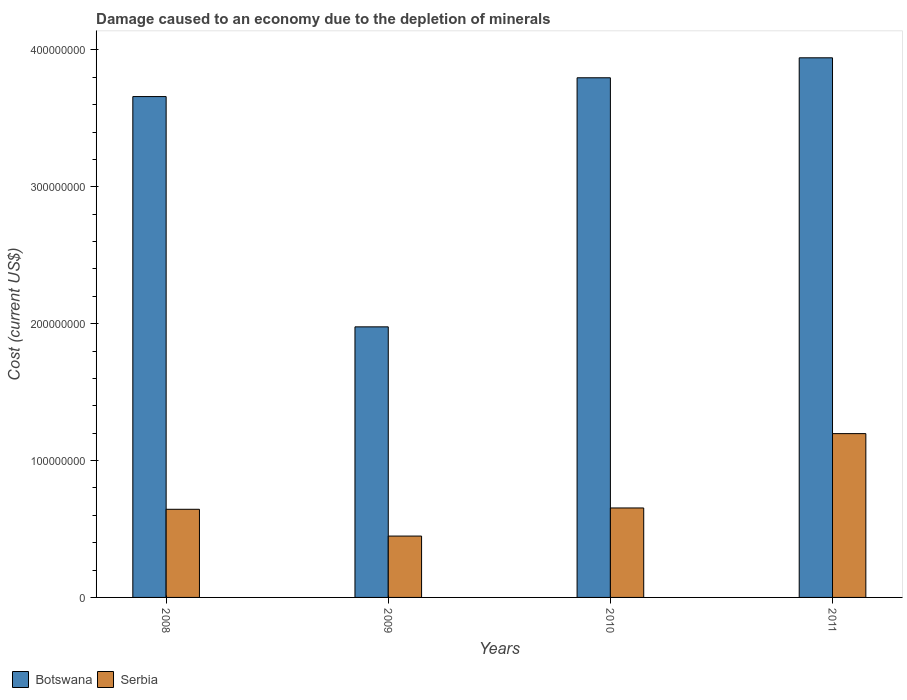How many different coloured bars are there?
Your answer should be compact. 2. How many groups of bars are there?
Offer a very short reply. 4. Are the number of bars per tick equal to the number of legend labels?
Your answer should be very brief. Yes. Are the number of bars on each tick of the X-axis equal?
Make the answer very short. Yes. How many bars are there on the 1st tick from the right?
Give a very brief answer. 2. What is the label of the 2nd group of bars from the left?
Make the answer very short. 2009. What is the cost of damage caused due to the depletion of minerals in Serbia in 2011?
Offer a very short reply. 1.20e+08. Across all years, what is the maximum cost of damage caused due to the depletion of minerals in Serbia?
Offer a very short reply. 1.20e+08. Across all years, what is the minimum cost of damage caused due to the depletion of minerals in Botswana?
Provide a short and direct response. 1.98e+08. What is the total cost of damage caused due to the depletion of minerals in Botswana in the graph?
Ensure brevity in your answer.  1.34e+09. What is the difference between the cost of damage caused due to the depletion of minerals in Botswana in 2008 and that in 2010?
Provide a short and direct response. -1.37e+07. What is the difference between the cost of damage caused due to the depletion of minerals in Botswana in 2011 and the cost of damage caused due to the depletion of minerals in Serbia in 2010?
Make the answer very short. 3.29e+08. What is the average cost of damage caused due to the depletion of minerals in Botswana per year?
Ensure brevity in your answer.  3.34e+08. In the year 2010, what is the difference between the cost of damage caused due to the depletion of minerals in Serbia and cost of damage caused due to the depletion of minerals in Botswana?
Your response must be concise. -3.14e+08. What is the ratio of the cost of damage caused due to the depletion of minerals in Serbia in 2009 to that in 2010?
Your answer should be very brief. 0.69. Is the cost of damage caused due to the depletion of minerals in Serbia in 2009 less than that in 2010?
Offer a very short reply. Yes. Is the difference between the cost of damage caused due to the depletion of minerals in Serbia in 2009 and 2011 greater than the difference between the cost of damage caused due to the depletion of minerals in Botswana in 2009 and 2011?
Offer a terse response. Yes. What is the difference between the highest and the second highest cost of damage caused due to the depletion of minerals in Serbia?
Make the answer very short. 5.43e+07. What is the difference between the highest and the lowest cost of damage caused due to the depletion of minerals in Botswana?
Keep it short and to the point. 1.97e+08. What does the 1st bar from the left in 2010 represents?
Give a very brief answer. Botswana. What does the 2nd bar from the right in 2010 represents?
Give a very brief answer. Botswana. How many bars are there?
Offer a terse response. 8. Are all the bars in the graph horizontal?
Your response must be concise. No. How many years are there in the graph?
Your response must be concise. 4. Are the values on the major ticks of Y-axis written in scientific E-notation?
Your response must be concise. No. Does the graph contain any zero values?
Give a very brief answer. No. Where does the legend appear in the graph?
Ensure brevity in your answer.  Bottom left. What is the title of the graph?
Offer a terse response. Damage caused to an economy due to the depletion of minerals. What is the label or title of the Y-axis?
Keep it short and to the point. Cost (current US$). What is the Cost (current US$) in Botswana in 2008?
Provide a succinct answer. 3.66e+08. What is the Cost (current US$) of Serbia in 2008?
Keep it short and to the point. 6.44e+07. What is the Cost (current US$) of Botswana in 2009?
Make the answer very short. 1.98e+08. What is the Cost (current US$) of Serbia in 2009?
Give a very brief answer. 4.48e+07. What is the Cost (current US$) of Botswana in 2010?
Provide a short and direct response. 3.80e+08. What is the Cost (current US$) in Serbia in 2010?
Give a very brief answer. 6.54e+07. What is the Cost (current US$) of Botswana in 2011?
Provide a succinct answer. 3.94e+08. What is the Cost (current US$) in Serbia in 2011?
Ensure brevity in your answer.  1.20e+08. Across all years, what is the maximum Cost (current US$) in Botswana?
Make the answer very short. 3.94e+08. Across all years, what is the maximum Cost (current US$) of Serbia?
Your answer should be compact. 1.20e+08. Across all years, what is the minimum Cost (current US$) of Botswana?
Your answer should be compact. 1.98e+08. Across all years, what is the minimum Cost (current US$) in Serbia?
Keep it short and to the point. 4.48e+07. What is the total Cost (current US$) of Botswana in the graph?
Your answer should be very brief. 1.34e+09. What is the total Cost (current US$) in Serbia in the graph?
Offer a terse response. 2.94e+08. What is the difference between the Cost (current US$) in Botswana in 2008 and that in 2009?
Ensure brevity in your answer.  1.68e+08. What is the difference between the Cost (current US$) in Serbia in 2008 and that in 2009?
Your answer should be very brief. 1.96e+07. What is the difference between the Cost (current US$) in Botswana in 2008 and that in 2010?
Provide a succinct answer. -1.37e+07. What is the difference between the Cost (current US$) of Serbia in 2008 and that in 2010?
Make the answer very short. -9.62e+05. What is the difference between the Cost (current US$) of Botswana in 2008 and that in 2011?
Your answer should be very brief. -2.83e+07. What is the difference between the Cost (current US$) in Serbia in 2008 and that in 2011?
Give a very brief answer. -5.53e+07. What is the difference between the Cost (current US$) in Botswana in 2009 and that in 2010?
Your response must be concise. -1.82e+08. What is the difference between the Cost (current US$) in Serbia in 2009 and that in 2010?
Offer a terse response. -2.05e+07. What is the difference between the Cost (current US$) in Botswana in 2009 and that in 2011?
Give a very brief answer. -1.97e+08. What is the difference between the Cost (current US$) in Serbia in 2009 and that in 2011?
Your answer should be very brief. -7.49e+07. What is the difference between the Cost (current US$) in Botswana in 2010 and that in 2011?
Provide a short and direct response. -1.46e+07. What is the difference between the Cost (current US$) in Serbia in 2010 and that in 2011?
Your answer should be compact. -5.43e+07. What is the difference between the Cost (current US$) in Botswana in 2008 and the Cost (current US$) in Serbia in 2009?
Your answer should be very brief. 3.21e+08. What is the difference between the Cost (current US$) in Botswana in 2008 and the Cost (current US$) in Serbia in 2010?
Make the answer very short. 3.01e+08. What is the difference between the Cost (current US$) of Botswana in 2008 and the Cost (current US$) of Serbia in 2011?
Offer a very short reply. 2.46e+08. What is the difference between the Cost (current US$) in Botswana in 2009 and the Cost (current US$) in Serbia in 2010?
Provide a short and direct response. 1.32e+08. What is the difference between the Cost (current US$) in Botswana in 2009 and the Cost (current US$) in Serbia in 2011?
Offer a very short reply. 7.80e+07. What is the difference between the Cost (current US$) in Botswana in 2010 and the Cost (current US$) in Serbia in 2011?
Ensure brevity in your answer.  2.60e+08. What is the average Cost (current US$) of Botswana per year?
Provide a short and direct response. 3.34e+08. What is the average Cost (current US$) of Serbia per year?
Offer a terse response. 7.36e+07. In the year 2008, what is the difference between the Cost (current US$) of Botswana and Cost (current US$) of Serbia?
Your answer should be compact. 3.02e+08. In the year 2009, what is the difference between the Cost (current US$) in Botswana and Cost (current US$) in Serbia?
Your answer should be compact. 1.53e+08. In the year 2010, what is the difference between the Cost (current US$) of Botswana and Cost (current US$) of Serbia?
Offer a very short reply. 3.14e+08. In the year 2011, what is the difference between the Cost (current US$) in Botswana and Cost (current US$) in Serbia?
Your response must be concise. 2.75e+08. What is the ratio of the Cost (current US$) in Botswana in 2008 to that in 2009?
Your response must be concise. 1.85. What is the ratio of the Cost (current US$) of Serbia in 2008 to that in 2009?
Provide a short and direct response. 1.44. What is the ratio of the Cost (current US$) in Botswana in 2008 to that in 2010?
Provide a short and direct response. 0.96. What is the ratio of the Cost (current US$) of Botswana in 2008 to that in 2011?
Give a very brief answer. 0.93. What is the ratio of the Cost (current US$) in Serbia in 2008 to that in 2011?
Your answer should be compact. 0.54. What is the ratio of the Cost (current US$) of Botswana in 2009 to that in 2010?
Provide a succinct answer. 0.52. What is the ratio of the Cost (current US$) in Serbia in 2009 to that in 2010?
Your response must be concise. 0.69. What is the ratio of the Cost (current US$) of Botswana in 2009 to that in 2011?
Make the answer very short. 0.5. What is the ratio of the Cost (current US$) of Serbia in 2009 to that in 2011?
Provide a succinct answer. 0.37. What is the ratio of the Cost (current US$) of Botswana in 2010 to that in 2011?
Ensure brevity in your answer.  0.96. What is the ratio of the Cost (current US$) in Serbia in 2010 to that in 2011?
Provide a succinct answer. 0.55. What is the difference between the highest and the second highest Cost (current US$) of Botswana?
Make the answer very short. 1.46e+07. What is the difference between the highest and the second highest Cost (current US$) in Serbia?
Your answer should be compact. 5.43e+07. What is the difference between the highest and the lowest Cost (current US$) in Botswana?
Keep it short and to the point. 1.97e+08. What is the difference between the highest and the lowest Cost (current US$) in Serbia?
Give a very brief answer. 7.49e+07. 